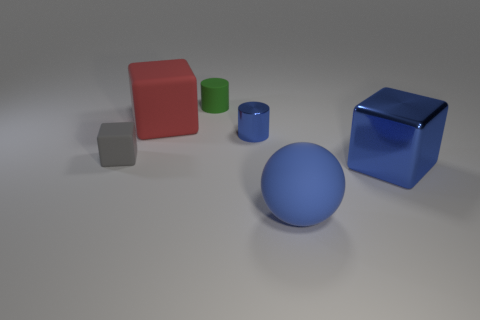There is a tiny metal cylinder; is it the same color as the block that is right of the tiny shiny cylinder?
Offer a terse response. Yes. There is a tiny cylinder that is the same color as the big metal cube; what material is it?
Keep it short and to the point. Metal. There is a metal cylinder that is the same color as the sphere; what is its size?
Your answer should be compact. Small. The rubber thing that is in front of the green thing and behind the tiny blue shiny cylinder is what color?
Ensure brevity in your answer.  Red. The thing that is made of the same material as the tiny blue cylinder is what shape?
Offer a very short reply. Cube. How many matte things are in front of the red cube and behind the large blue ball?
Your response must be concise. 1. There is a red rubber thing; are there any tiny matte cubes right of it?
Provide a succinct answer. No. There is a small rubber thing behind the blue metal cylinder; is it the same shape as the large rubber object behind the small metal cylinder?
Provide a short and direct response. No. What number of objects are either large blue matte balls or blocks that are to the left of the large red rubber block?
Offer a terse response. 2. How many other things are the same shape as the large red matte object?
Ensure brevity in your answer.  2. 